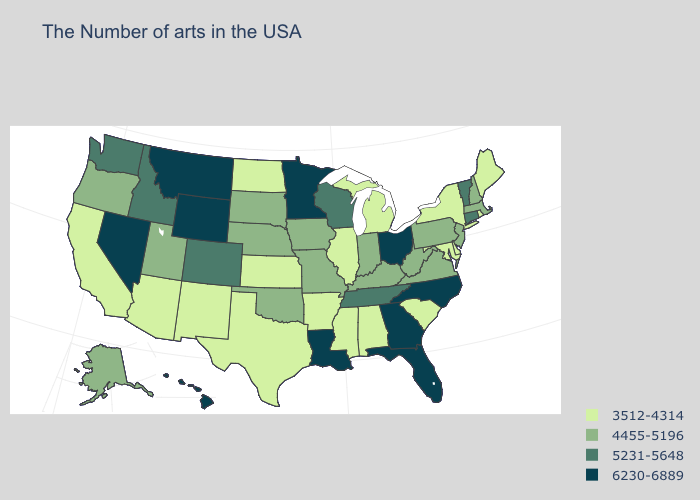Does Georgia have the highest value in the South?
Answer briefly. Yes. Does the map have missing data?
Short answer required. No. Does Kentucky have the same value as North Dakota?
Keep it brief. No. Among the states that border Virginia , which have the highest value?
Answer briefly. North Carolina. Name the states that have a value in the range 4455-5196?
Quick response, please. Massachusetts, New Hampshire, New Jersey, Pennsylvania, Virginia, West Virginia, Kentucky, Indiana, Missouri, Iowa, Nebraska, Oklahoma, South Dakota, Utah, Oregon, Alaska. What is the value of Texas?
Write a very short answer. 3512-4314. Name the states that have a value in the range 6230-6889?
Keep it brief. North Carolina, Ohio, Florida, Georgia, Louisiana, Minnesota, Wyoming, Montana, Nevada, Hawaii. Name the states that have a value in the range 5231-5648?
Write a very short answer. Vermont, Connecticut, Tennessee, Wisconsin, Colorado, Idaho, Washington. Name the states that have a value in the range 5231-5648?
Quick response, please. Vermont, Connecticut, Tennessee, Wisconsin, Colorado, Idaho, Washington. Among the states that border West Virginia , does Maryland have the lowest value?
Answer briefly. Yes. Among the states that border Idaho , which have the lowest value?
Write a very short answer. Utah, Oregon. Does Florida have the same value as Wyoming?
Give a very brief answer. Yes. What is the value of South Dakota?
Short answer required. 4455-5196. Among the states that border Wyoming , which have the lowest value?
Short answer required. Nebraska, South Dakota, Utah. How many symbols are there in the legend?
Write a very short answer. 4. 